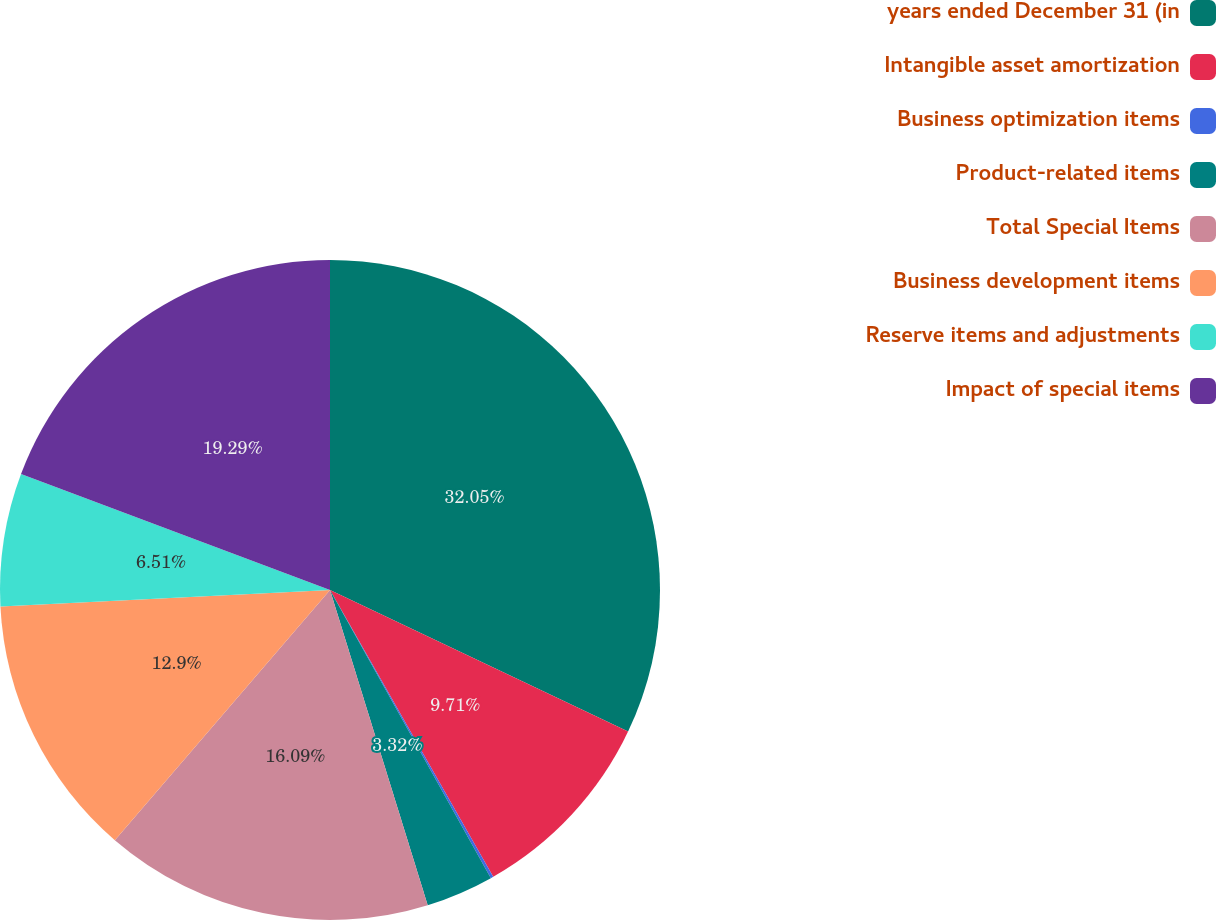Convert chart. <chart><loc_0><loc_0><loc_500><loc_500><pie_chart><fcel>years ended December 31 (in<fcel>Intangible asset amortization<fcel>Business optimization items<fcel>Product-related items<fcel>Total Special Items<fcel>Business development items<fcel>Reserve items and adjustments<fcel>Impact of special items<nl><fcel>32.06%<fcel>9.71%<fcel>0.13%<fcel>3.32%<fcel>16.09%<fcel>12.9%<fcel>6.51%<fcel>19.29%<nl></chart> 